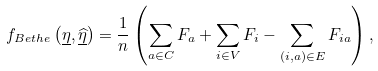<formula> <loc_0><loc_0><loc_500><loc_500>f _ { B e t h e } \left ( \underline { \eta } , \underline { \widehat { \eta } } \right ) = \frac { 1 } { n } \left ( \sum _ { a \in C } F _ { a } + \sum _ { i \in V } F _ { i } - \sum _ { \left ( i , a \right ) \in E } F _ { i a } \right ) ,</formula> 